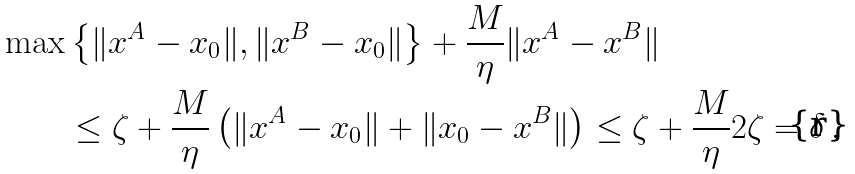<formula> <loc_0><loc_0><loc_500><loc_500>\max & \left \{ \| x ^ { A } - x _ { 0 } \| , \| x ^ { B } - x _ { 0 } \| \right \} + \frac { M } { \eta } \| x ^ { A } - x ^ { B } \| \\ & \leq \zeta + \frac { M } { \eta } \left ( \| x ^ { A } - x _ { 0 } \| + \| x _ { 0 } - x ^ { B } \| \right ) \leq \zeta + \frac { M } { \eta } 2 \zeta = \delta \, .</formula> 